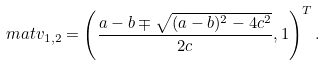Convert formula to latex. <formula><loc_0><loc_0><loc_500><loc_500>\ m a t { v } _ { 1 , 2 } = \left ( \frac { a - b \mp \sqrt { ( a - b ) ^ { 2 } - 4 c ^ { 2 } } } { 2 c } , 1 \right ) ^ { T } .</formula> 